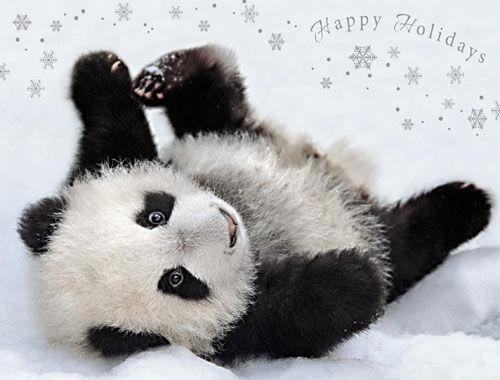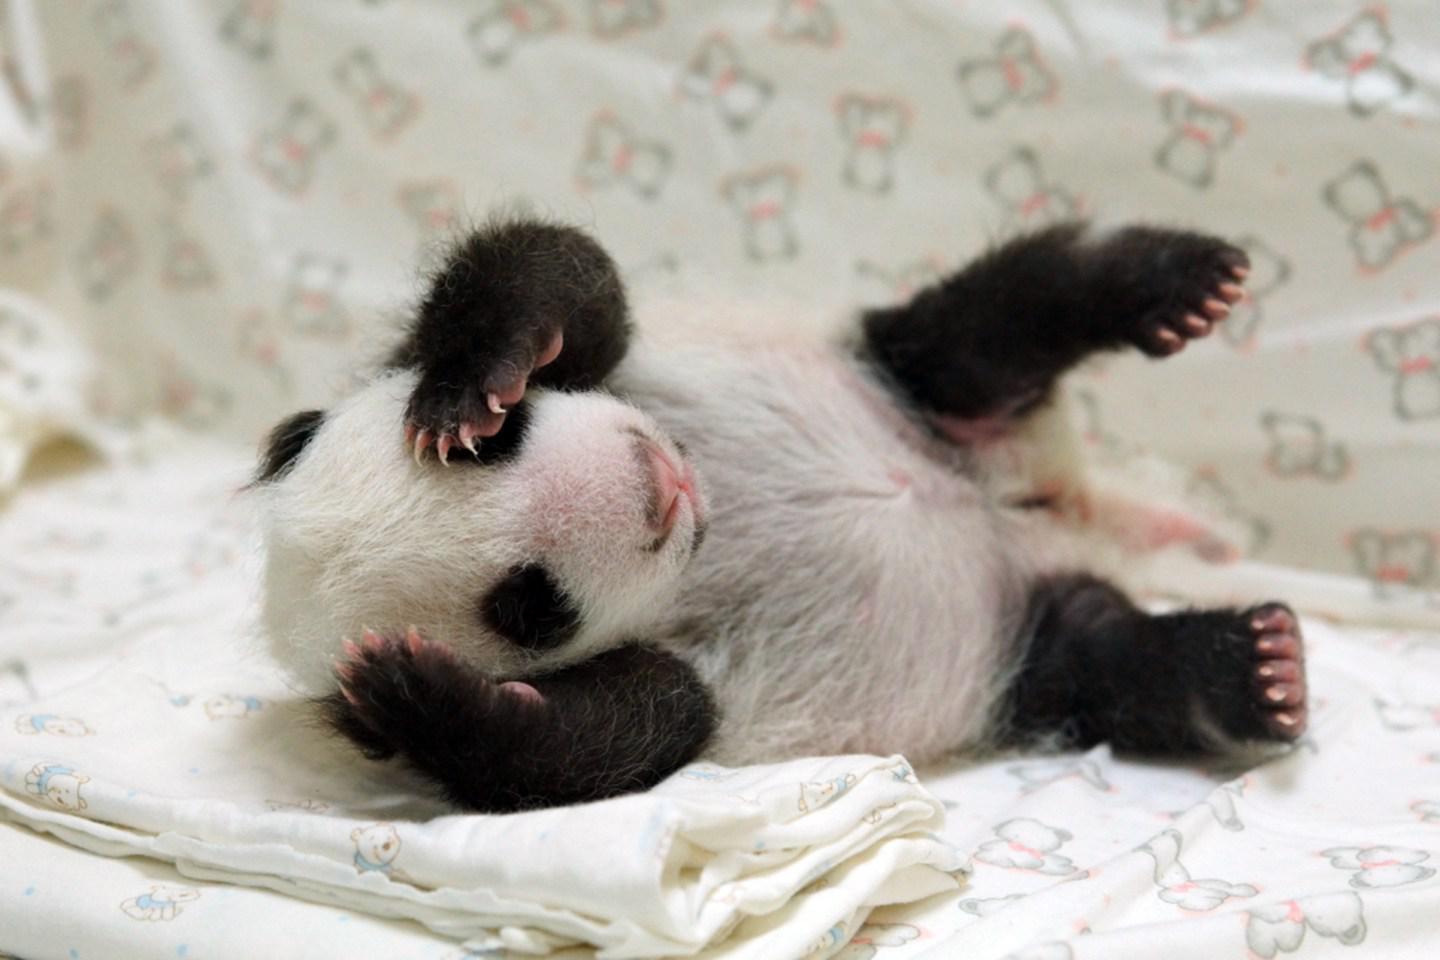The first image is the image on the left, the second image is the image on the right. Examine the images to the left and right. Is the description "The left and right image contains the same number of pandas." accurate? Answer yes or no. Yes. The first image is the image on the left, the second image is the image on the right. For the images shown, is this caption "The right image shows a baby panda with a pink nose and fuzzy fur, posed on a blanket with the toes of two limbs turning inward." true? Answer yes or no. Yes. 